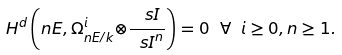<formula> <loc_0><loc_0><loc_500><loc_500>H ^ { d } \left ( n E , { \Omega } ^ { i } _ { { n E } / k } { \otimes } { \frac { \ s I } { { \ s I } ^ { n } } } \right ) = 0 \ \forall \ i \geq 0 , n \geq 1 .</formula> 